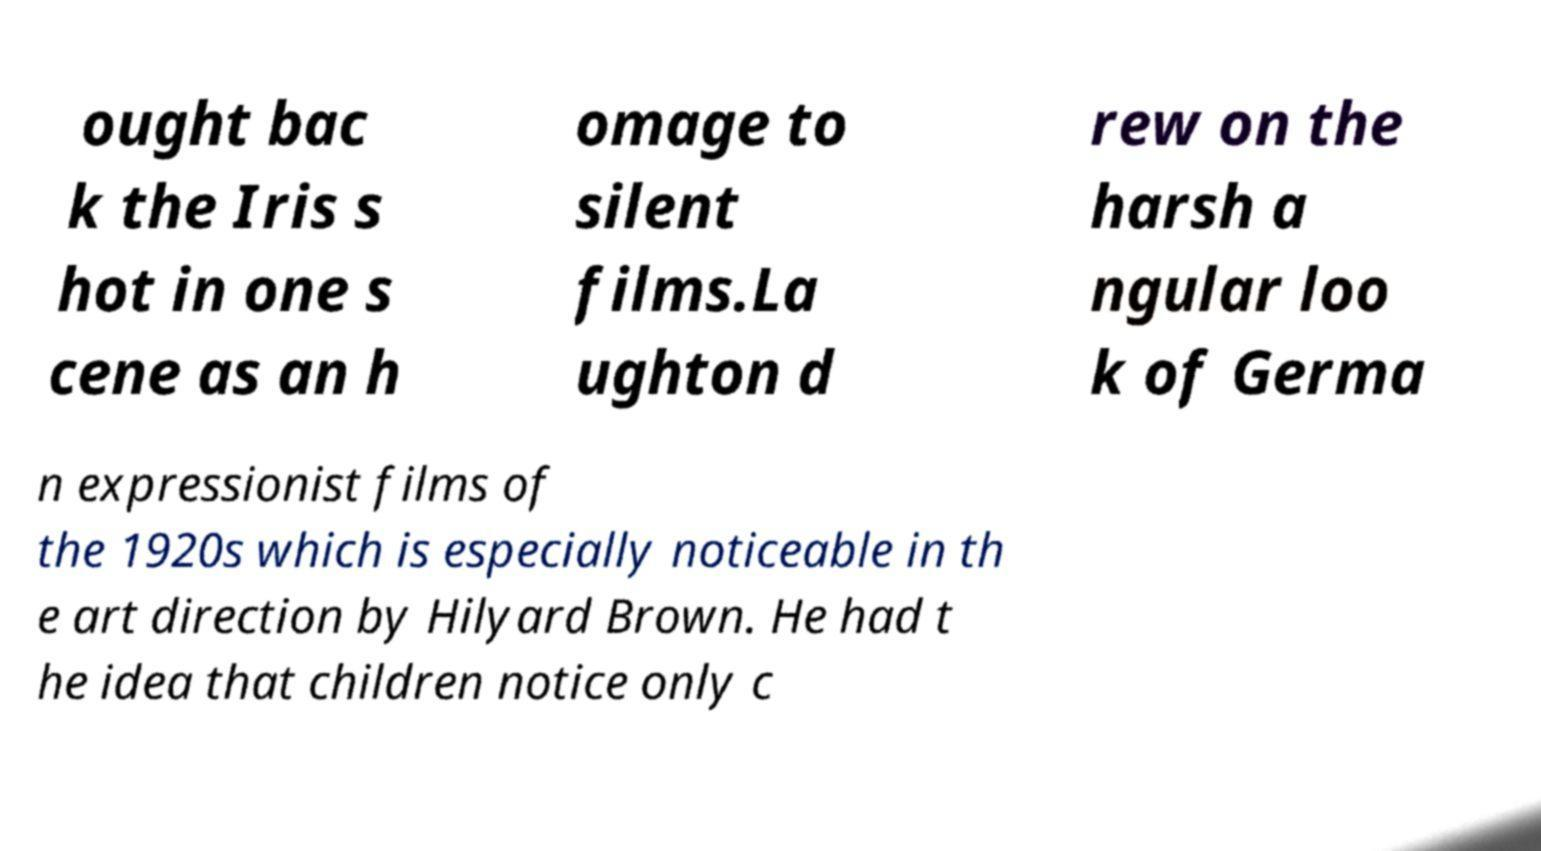Could you assist in decoding the text presented in this image and type it out clearly? ought bac k the Iris s hot in one s cene as an h omage to silent films.La ughton d rew on the harsh a ngular loo k of Germa n expressionist films of the 1920s which is especially noticeable in th e art direction by Hilyard Brown. He had t he idea that children notice only c 